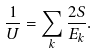<formula> <loc_0><loc_0><loc_500><loc_500>\frac { 1 } { U } = \sum _ { k } \frac { 2 S } { E _ { k } } .</formula> 